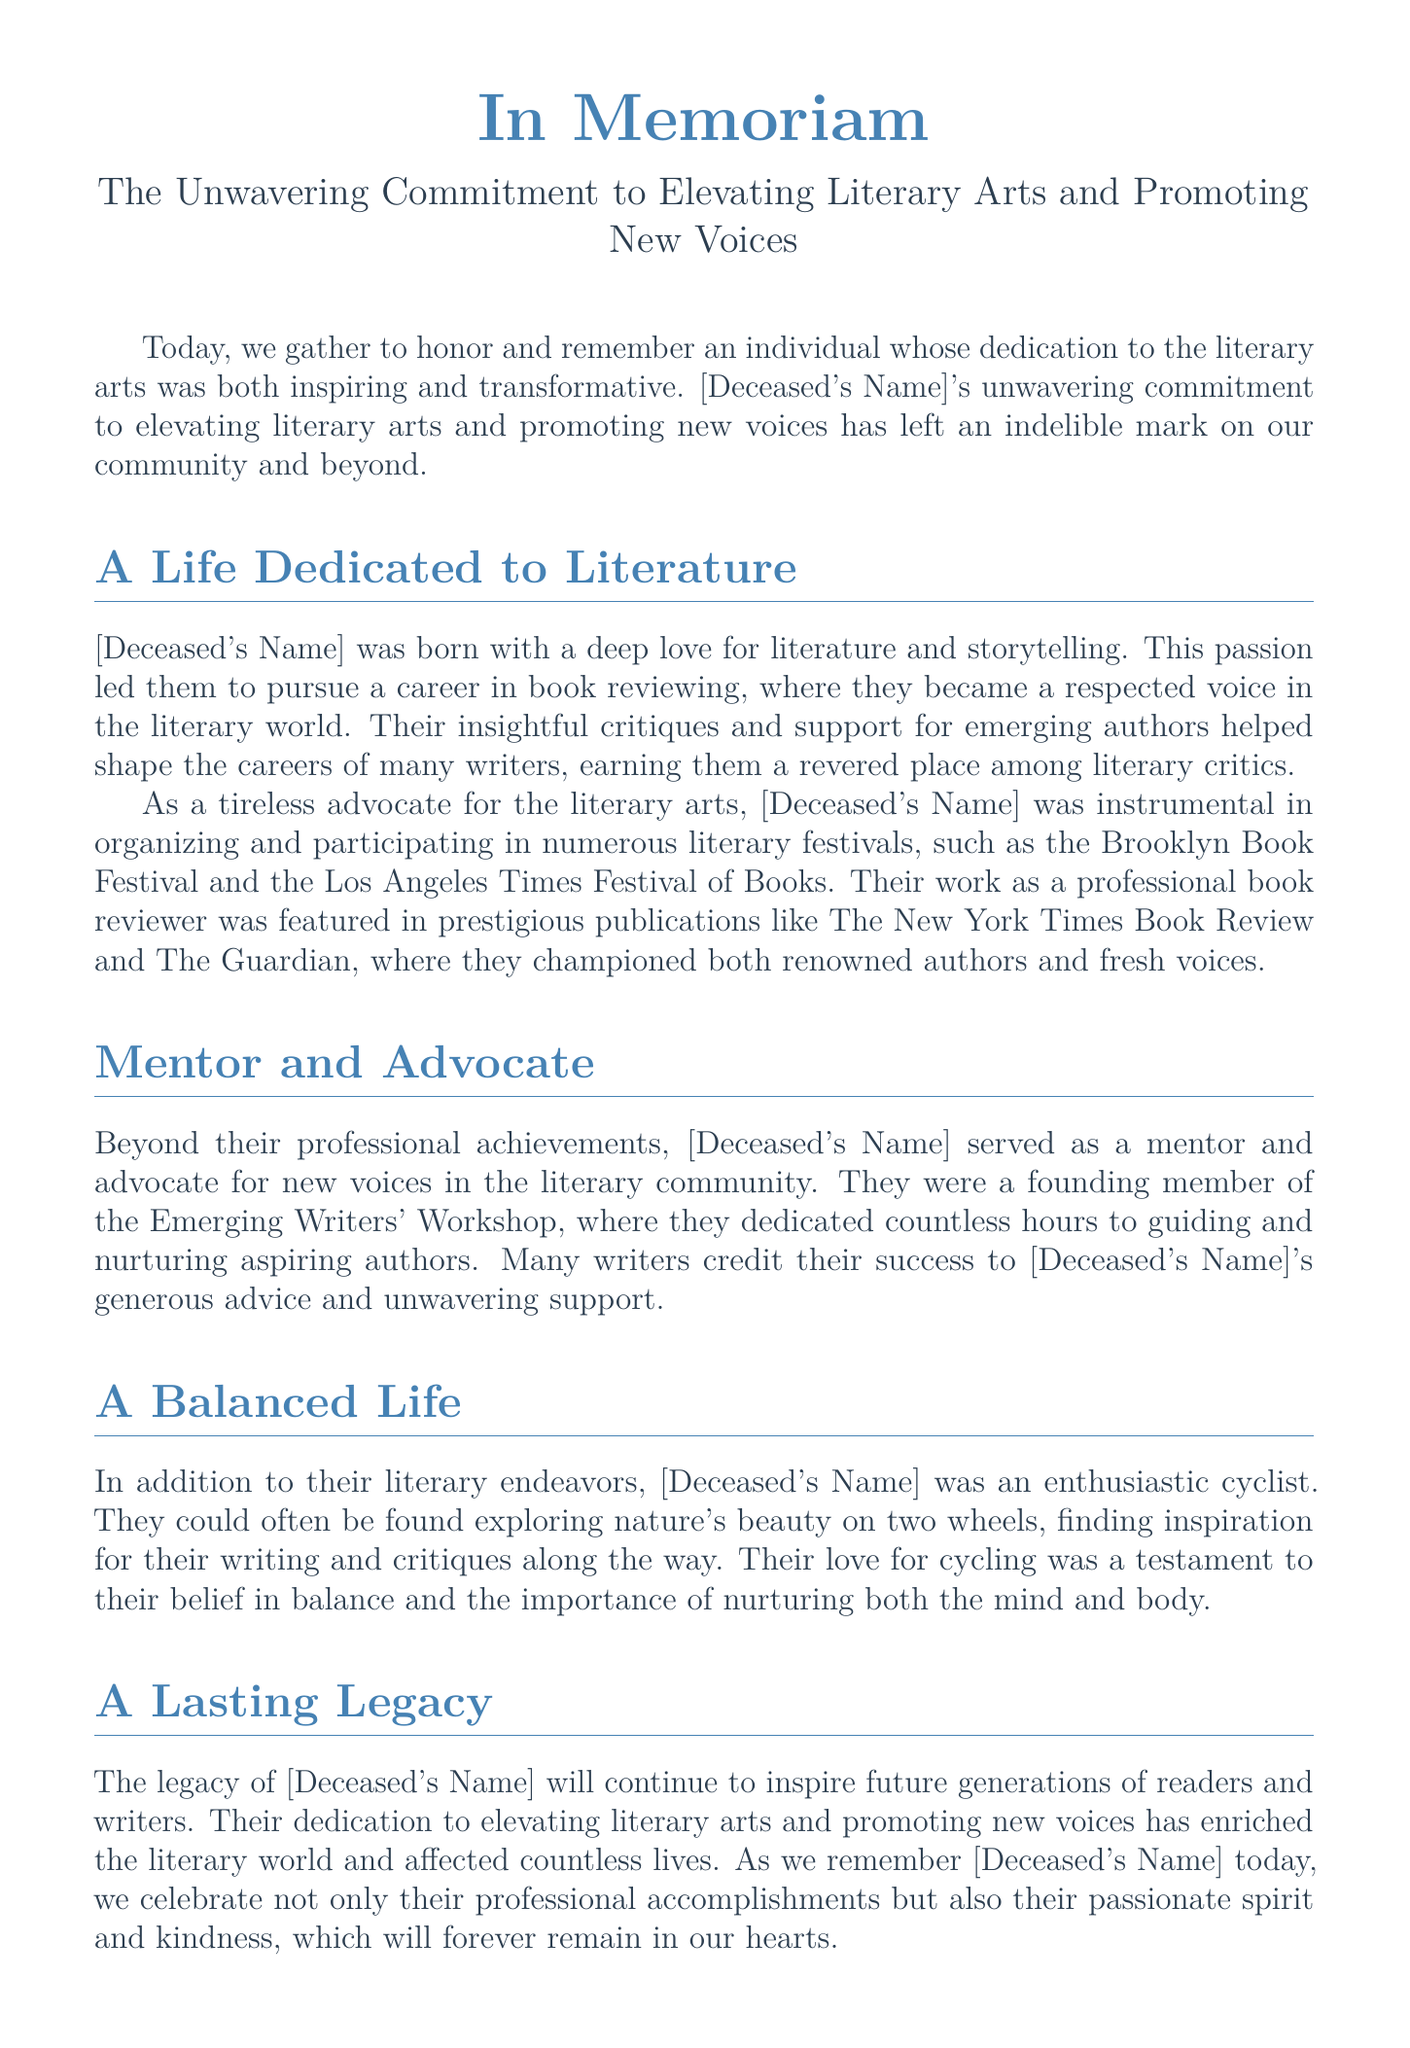What is the name of the individual being honored? The document references [Deceased's Name], a placeholder for the actual name which is not provided.
Answer: [Deceased's Name] What festivals was [Deceased's Name] involved in? The document mentions the Brooklyn Book Festival and the Los Angeles Times Festival of Books as events they participated in.
Answer: Brooklyn Book Festival, Los Angeles Times Festival of Books What role did [Deceased's Name] play in the Emerging Writers' Workshop? The document states that [Deceased's Name] was a founding member of the workshop, indicating a key role in its formation.
Answer: Founding member What did [Deceased's Name] do as a professional book reviewer? The document explains that their work was featured in prestigious publications and they supported emerging authors.
Answer: Championed authors What was [Deceased's Name]'s hobby besides literature? The text mentions that [Deceased's Name] was an enthusiastic cyclist, showcasing their other passion.
Answer: Cycling How did [Deceased's Name] view the balance in life? The document highlights [Deceased's Name]'s belief in balance, particularly in nurturing both the mind and body.
Answer: Importance of balance What is the main request or sentiment expressed at the end of the document? The conclusion expresses a wish for [Deceased's Name]'s love for literature and cycling to inspire others.
Answer: Inspire us all 